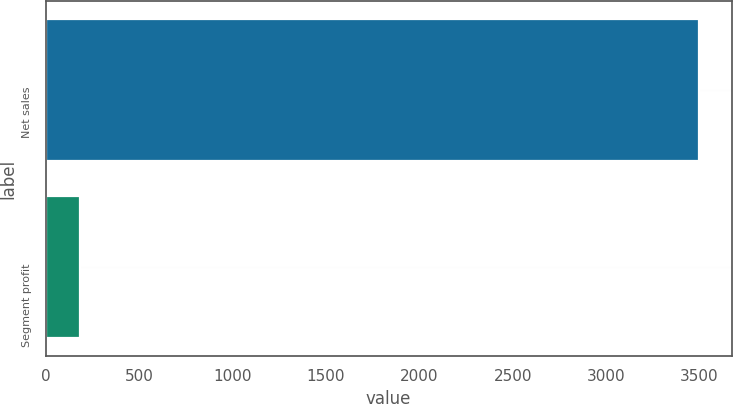<chart> <loc_0><loc_0><loc_500><loc_500><bar_chart><fcel>Net sales<fcel>Segment profit<nl><fcel>3497<fcel>184<nl></chart> 